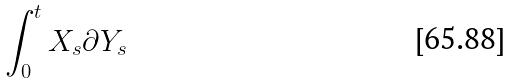Convert formula to latex. <formula><loc_0><loc_0><loc_500><loc_500>\int _ { 0 } ^ { t } X _ { s } \partial Y _ { s }</formula> 